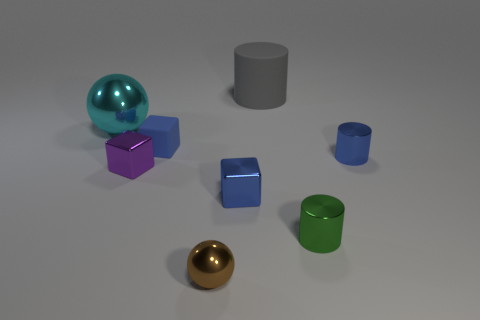Add 1 yellow metallic cylinders. How many objects exist? 9 Subtract all cubes. How many objects are left? 5 Add 8 big cyan cylinders. How many big cyan cylinders exist? 8 Subtract 0 brown cylinders. How many objects are left? 8 Subtract all large matte cylinders. Subtract all small purple shiny things. How many objects are left? 6 Add 8 big gray rubber things. How many big gray rubber things are left? 9 